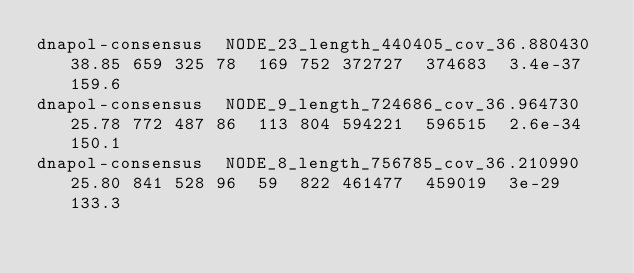Convert code to text. <code><loc_0><loc_0><loc_500><loc_500><_SQL_>dnapol-consensus	NODE_23_length_440405_cov_36.880430	38.85	659	325	78	169	752	372727	374683	3.4e-37	159.6
dnapol-consensus	NODE_9_length_724686_cov_36.964730	25.78	772	487	86	113	804	594221	596515	2.6e-34	150.1
dnapol-consensus	NODE_8_length_756785_cov_36.210990	25.80	841	528	96	59	822	461477	459019	3e-29	133.3</code> 